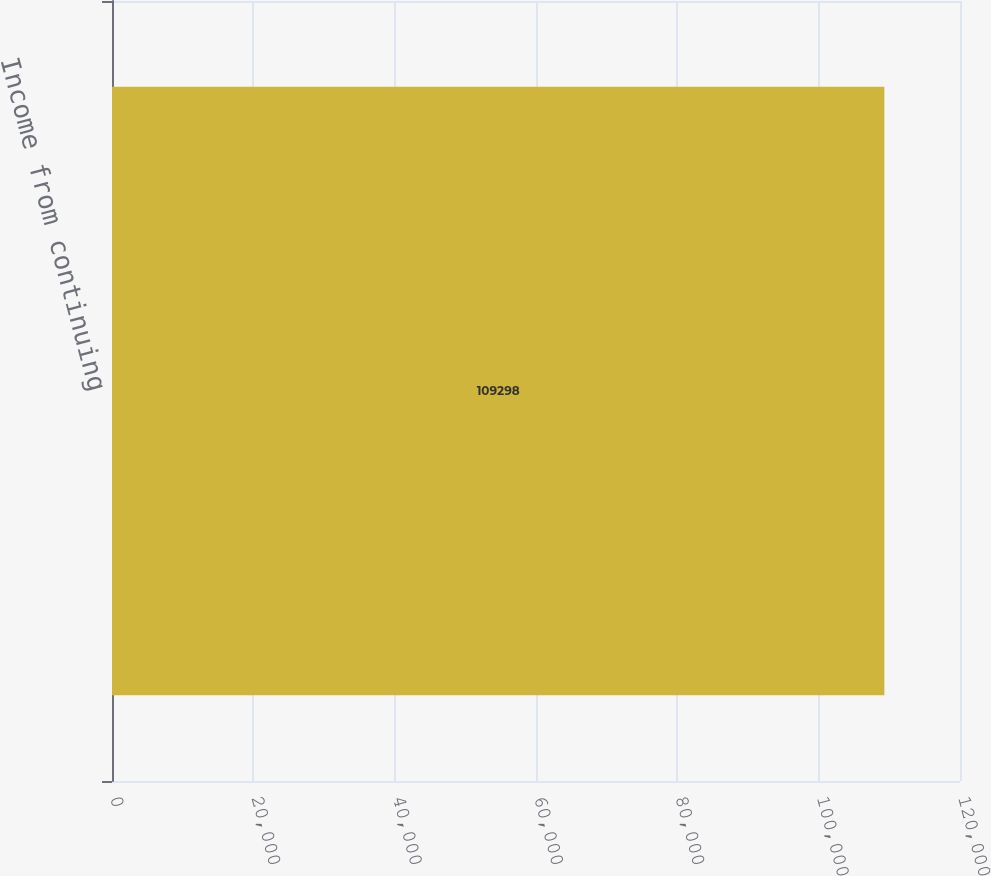Convert chart. <chart><loc_0><loc_0><loc_500><loc_500><bar_chart><fcel>Income from continuing<nl><fcel>109298<nl></chart> 